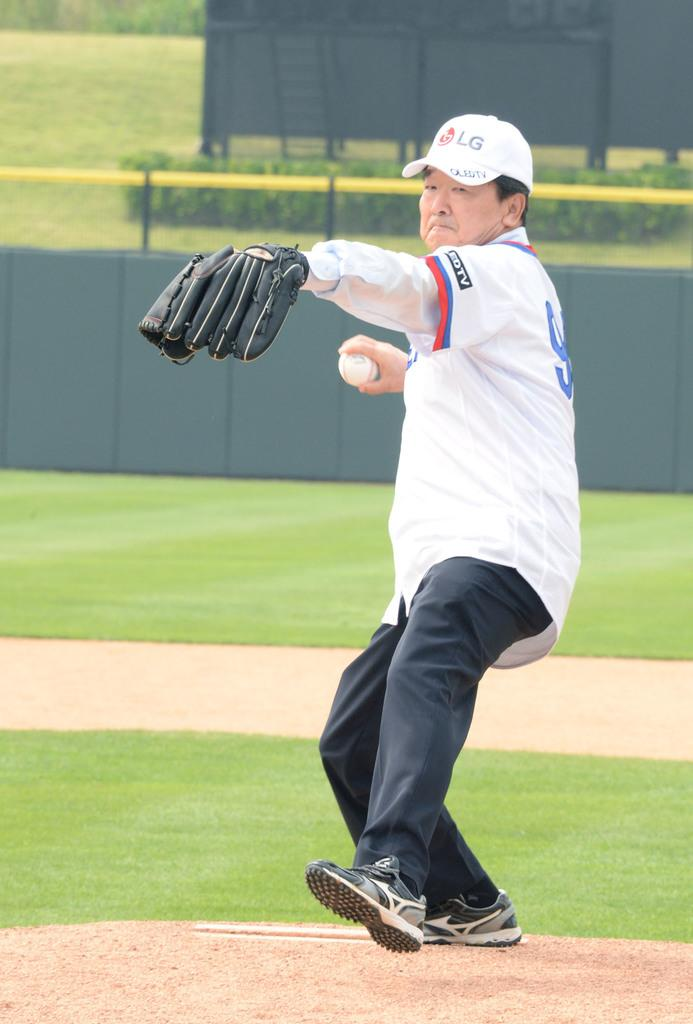<image>
Render a clear and concise summary of the photo. The man pitching the ball is wearing a hat with the company LG on the front. 